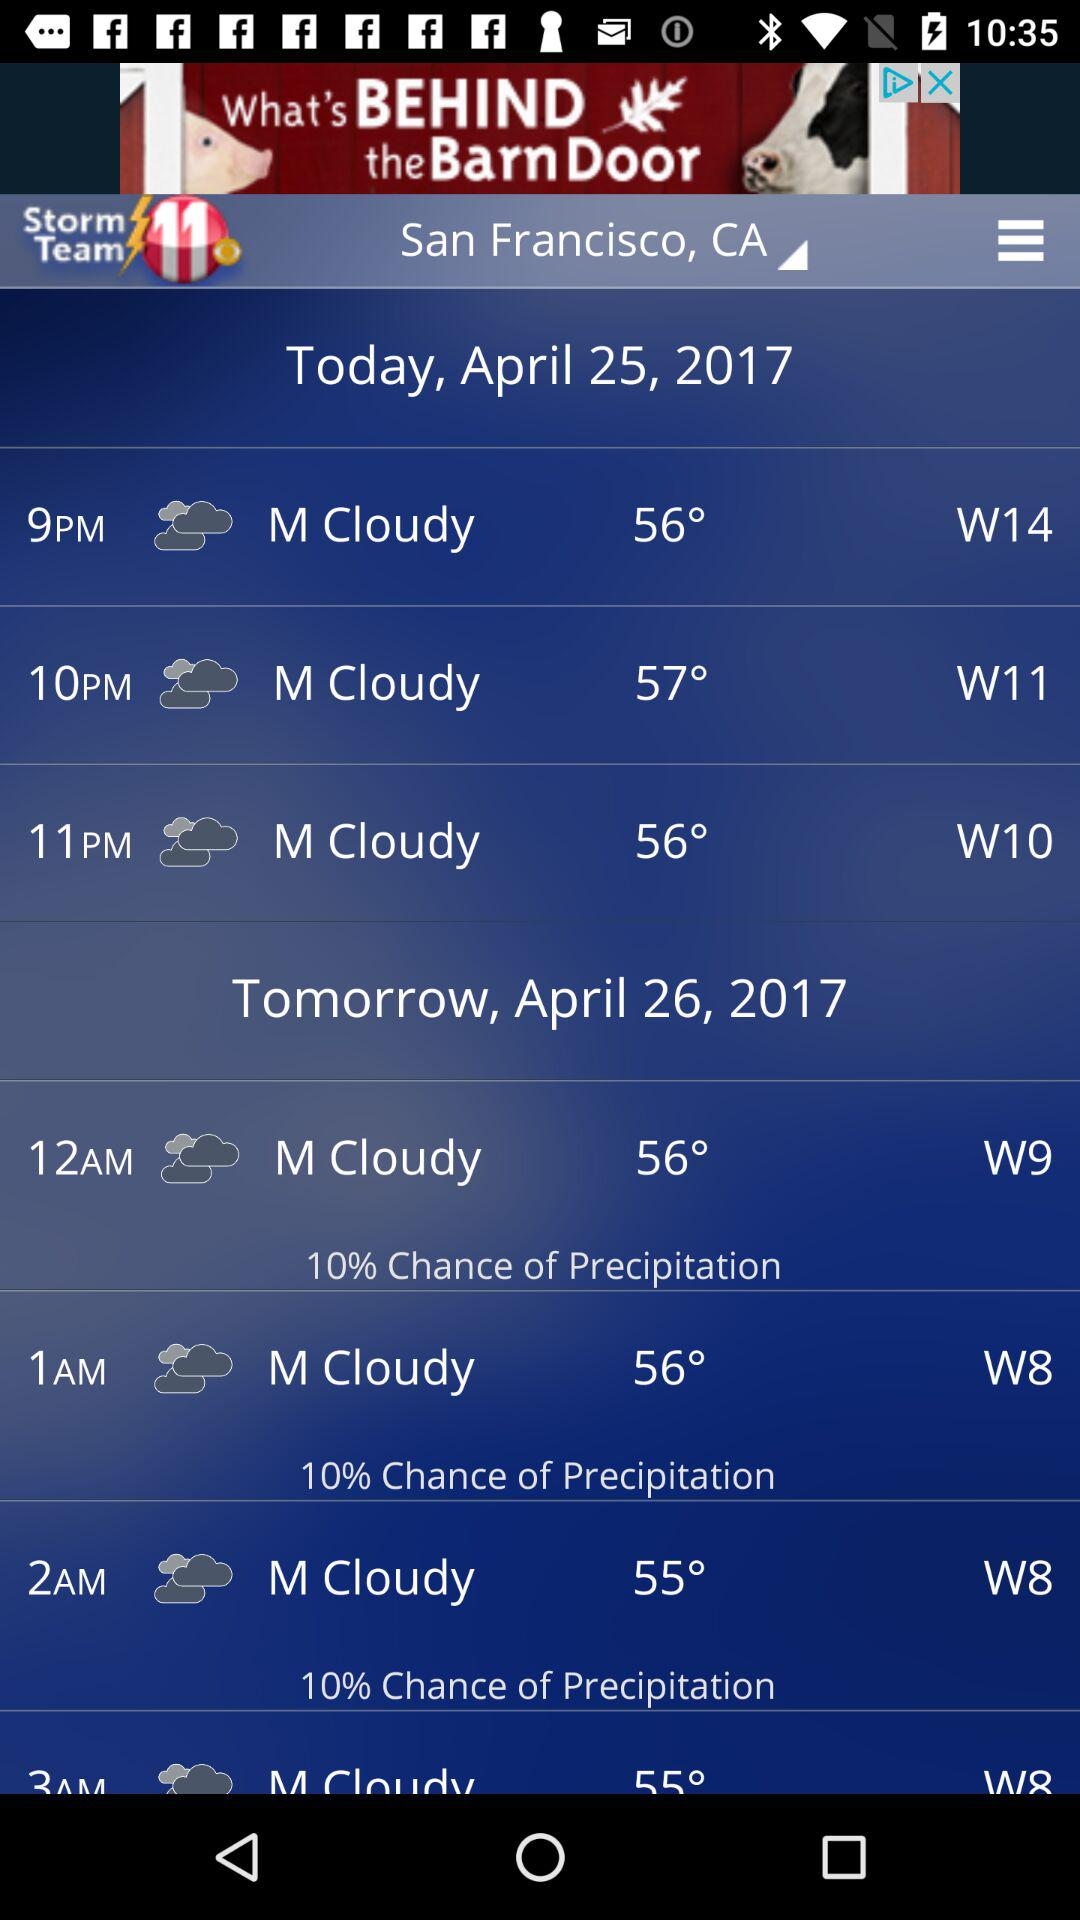What is the probability of precipitation for the day?
Answer the question using a single word or phrase. 10% 